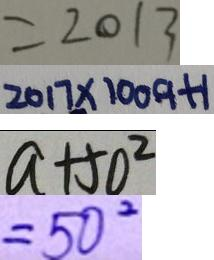Convert formula to latex. <formula><loc_0><loc_0><loc_500><loc_500>= 2 0 1 3 
 2 0 1 7 \times 1 0 0 9 + 1 
 a + 5 0 ^ { 2 } 
 = 5 0 ^ { 2 }</formula> 